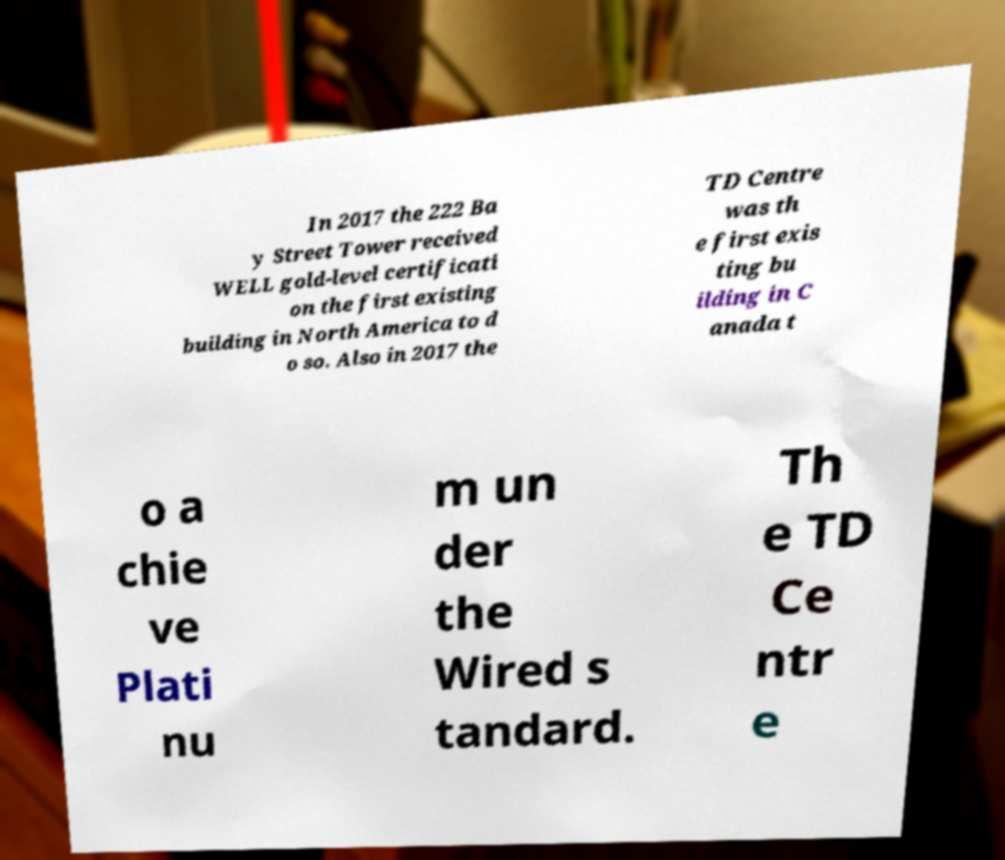Can you accurately transcribe the text from the provided image for me? In 2017 the 222 Ba y Street Tower received WELL gold-level certificati on the first existing building in North America to d o so. Also in 2017 the TD Centre was th e first exis ting bu ilding in C anada t o a chie ve Plati nu m un der the Wired s tandard. Th e TD Ce ntr e 